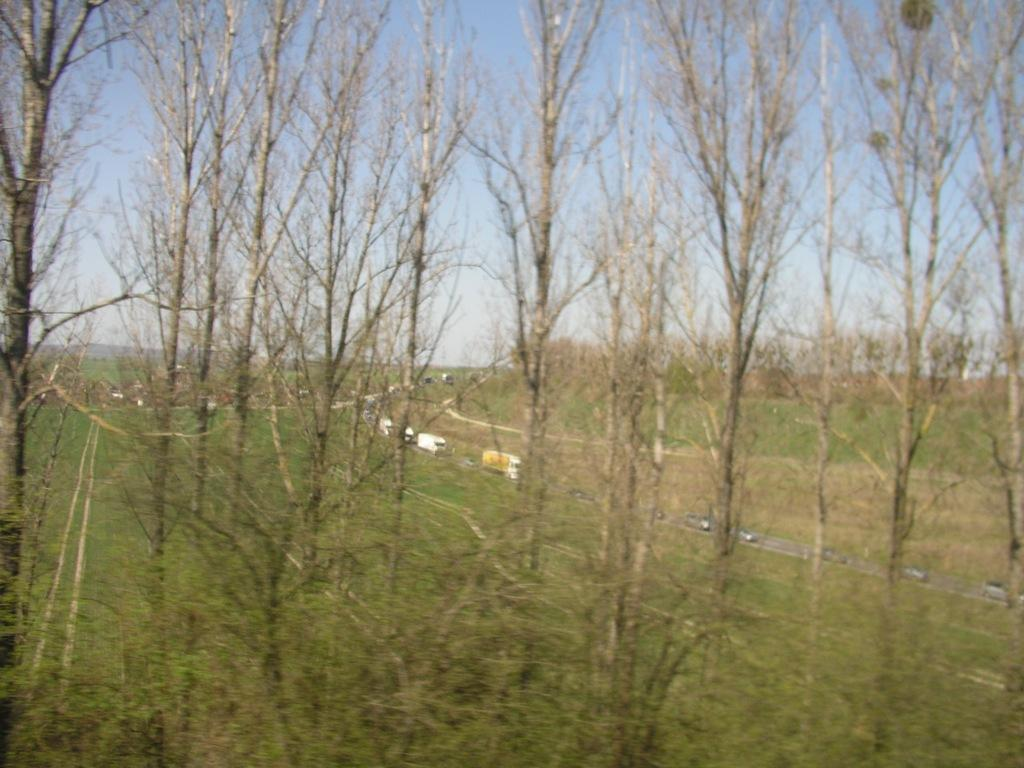What type of vegetation can be seen in the front of the image? There are dry trees in the front of the image. What is covering the land in the image? The land is covered with grass in the image. What part of the natural environment is visible in the image? The sky is visible in the image. How many sheep are grazing in the grass in the image? There are no sheep present in the image; it only features dry trees and grass-covered land. What type of pot can be seen on the dry trees in the image? There is no pot present on the dry trees in the image. 